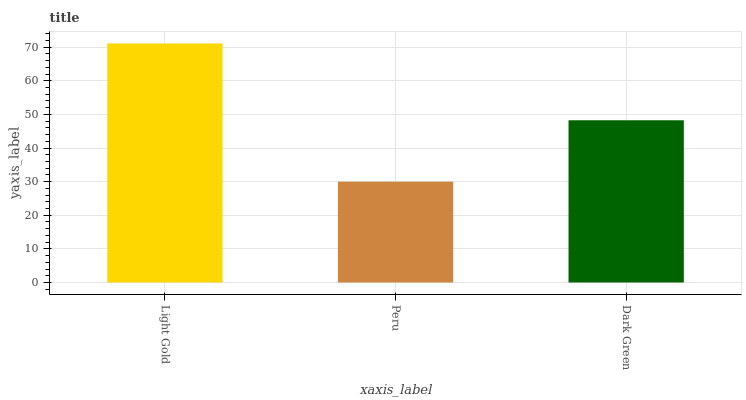Is Peru the minimum?
Answer yes or no. Yes. Is Light Gold the maximum?
Answer yes or no. Yes. Is Dark Green the minimum?
Answer yes or no. No. Is Dark Green the maximum?
Answer yes or no. No. Is Dark Green greater than Peru?
Answer yes or no. Yes. Is Peru less than Dark Green?
Answer yes or no. Yes. Is Peru greater than Dark Green?
Answer yes or no. No. Is Dark Green less than Peru?
Answer yes or no. No. Is Dark Green the high median?
Answer yes or no. Yes. Is Dark Green the low median?
Answer yes or no. Yes. Is Light Gold the high median?
Answer yes or no. No. Is Peru the low median?
Answer yes or no. No. 